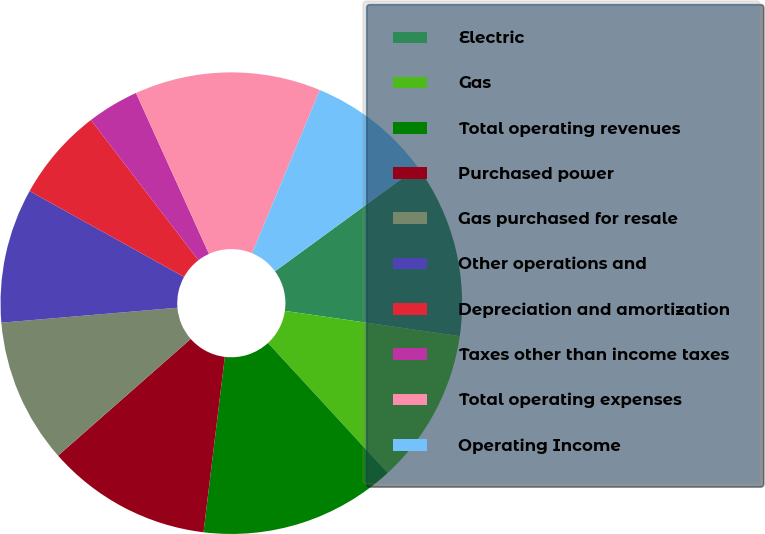Convert chart to OTSL. <chart><loc_0><loc_0><loc_500><loc_500><pie_chart><fcel>Electric<fcel>Gas<fcel>Total operating revenues<fcel>Purchased power<fcel>Gas purchased for resale<fcel>Other operations and<fcel>Depreciation and amortization<fcel>Taxes other than income taxes<fcel>Total operating expenses<fcel>Operating Income<nl><fcel>12.32%<fcel>10.87%<fcel>13.77%<fcel>11.59%<fcel>10.14%<fcel>9.42%<fcel>6.52%<fcel>3.63%<fcel>13.04%<fcel>8.7%<nl></chart> 